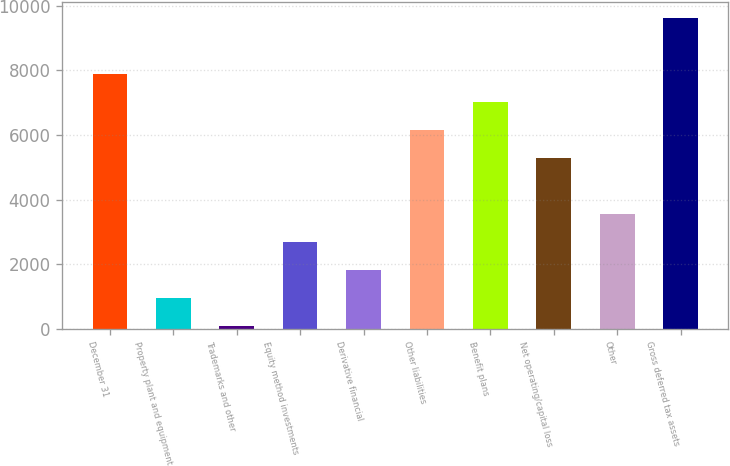<chart> <loc_0><loc_0><loc_500><loc_500><bar_chart><fcel>December 31<fcel>Property plant and equipment<fcel>Trademarks and other<fcel>Equity method investments<fcel>Derivative financial<fcel>Other liabilities<fcel>Benefit plans<fcel>Net operating/capital loss<fcel>Other<fcel>Gross deferred tax assets<nl><fcel>7889<fcel>945<fcel>77<fcel>2681<fcel>1813<fcel>6153<fcel>7021<fcel>5285<fcel>3549<fcel>9625<nl></chart> 